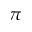Convert formula to latex. <formula><loc_0><loc_0><loc_500><loc_500>\pi</formula> 